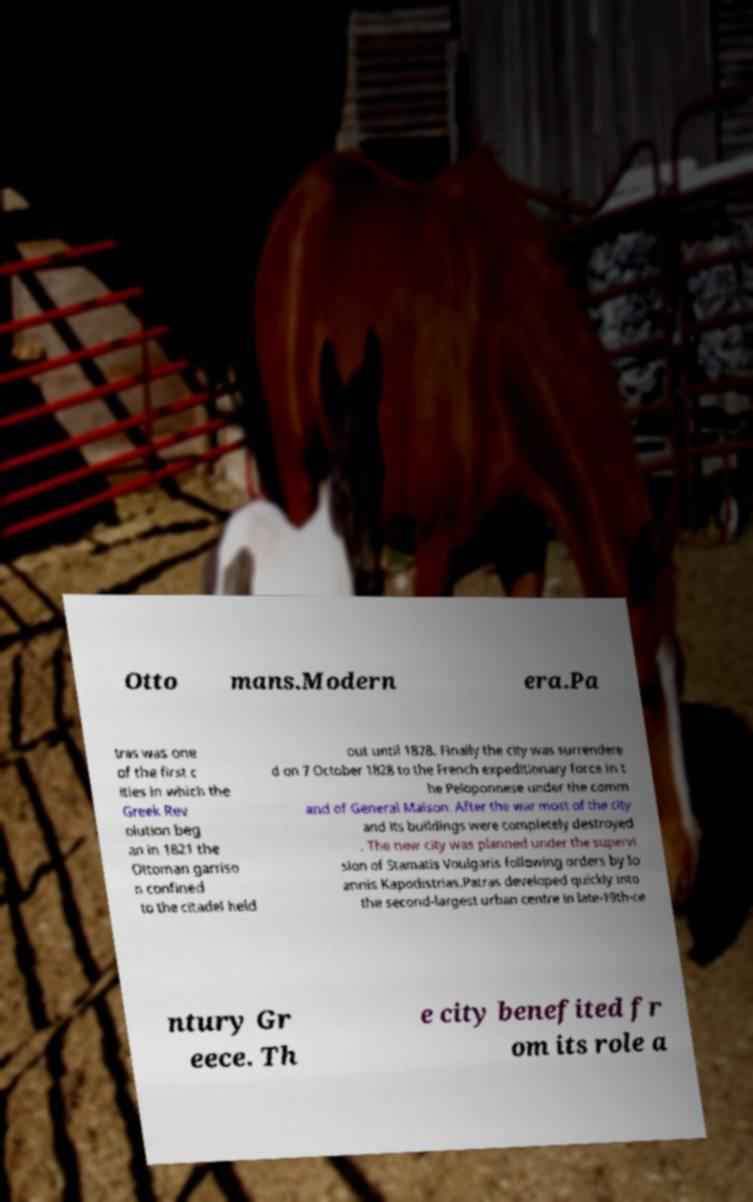There's text embedded in this image that I need extracted. Can you transcribe it verbatim? Otto mans.Modern era.Pa tras was one of the first c ities in which the Greek Rev olution beg an in 1821 the Ottoman garriso n confined to the citadel held out until 1828. Finally the city was surrendere d on 7 October 1828 to the French expeditionary force in t he Peloponnese under the comm and of General Maison. After the war most of the city and its buildings were completely destroyed . The new city was planned under the supervi sion of Stamatis Voulgaris following orders by Io annis Kapodistrias.Patras developed quickly into the second-largest urban centre in late-19th-ce ntury Gr eece. Th e city benefited fr om its role a 